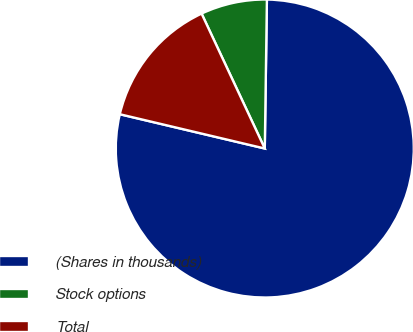Convert chart. <chart><loc_0><loc_0><loc_500><loc_500><pie_chart><fcel>(Shares in thousands)<fcel>Stock options<fcel>Total<nl><fcel>78.47%<fcel>7.2%<fcel>14.33%<nl></chart> 